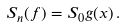<formula> <loc_0><loc_0><loc_500><loc_500>S _ { n } ( f ) = S _ { 0 } g ( x ) \, .</formula> 